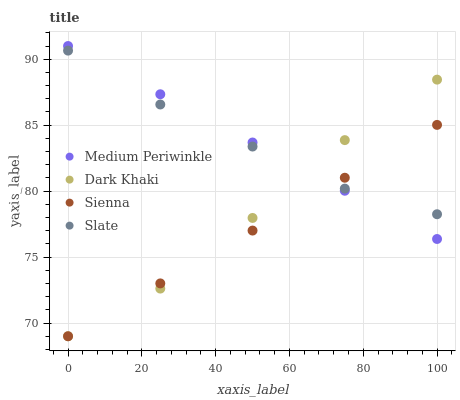Does Sienna have the minimum area under the curve?
Answer yes or no. Yes. Does Medium Periwinkle have the maximum area under the curve?
Answer yes or no. Yes. Does Slate have the minimum area under the curve?
Answer yes or no. No. Does Slate have the maximum area under the curve?
Answer yes or no. No. Is Sienna the smoothest?
Answer yes or no. Yes. Is Dark Khaki the roughest?
Answer yes or no. Yes. Is Slate the smoothest?
Answer yes or no. No. Is Slate the roughest?
Answer yes or no. No. Does Dark Khaki have the lowest value?
Answer yes or no. Yes. Does Slate have the lowest value?
Answer yes or no. No. Does Medium Periwinkle have the highest value?
Answer yes or no. Yes. Does Slate have the highest value?
Answer yes or no. No. Does Dark Khaki intersect Slate?
Answer yes or no. Yes. Is Dark Khaki less than Slate?
Answer yes or no. No. Is Dark Khaki greater than Slate?
Answer yes or no. No. 